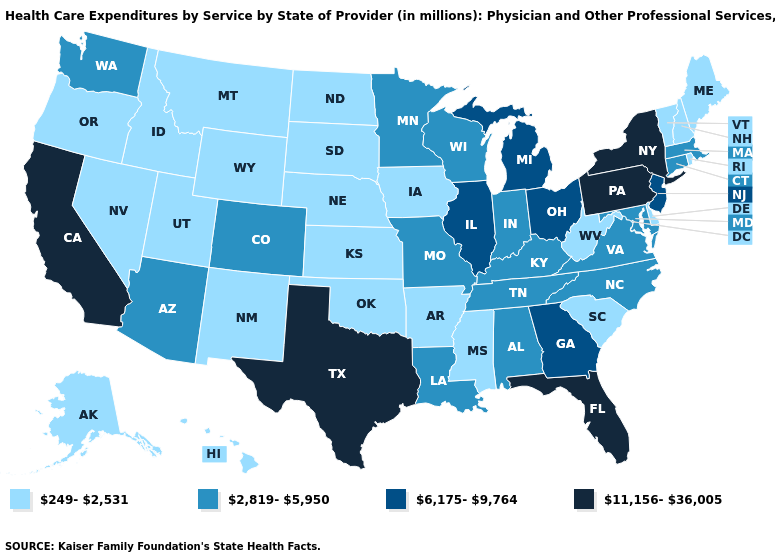Does Texas have the highest value in the USA?
Answer briefly. Yes. Among the states that border South Dakota , which have the highest value?
Give a very brief answer. Minnesota. Name the states that have a value in the range 249-2,531?
Answer briefly. Alaska, Arkansas, Delaware, Hawaii, Idaho, Iowa, Kansas, Maine, Mississippi, Montana, Nebraska, Nevada, New Hampshire, New Mexico, North Dakota, Oklahoma, Oregon, Rhode Island, South Carolina, South Dakota, Utah, Vermont, West Virginia, Wyoming. Name the states that have a value in the range 11,156-36,005?
Quick response, please. California, Florida, New York, Pennsylvania, Texas. Is the legend a continuous bar?
Concise answer only. No. Name the states that have a value in the range 6,175-9,764?
Short answer required. Georgia, Illinois, Michigan, New Jersey, Ohio. Does the first symbol in the legend represent the smallest category?
Quick response, please. Yes. What is the value of California?
Give a very brief answer. 11,156-36,005. Name the states that have a value in the range 6,175-9,764?
Write a very short answer. Georgia, Illinois, Michigan, New Jersey, Ohio. Name the states that have a value in the range 6,175-9,764?
Be succinct. Georgia, Illinois, Michigan, New Jersey, Ohio. Does the map have missing data?
Be succinct. No. Which states have the highest value in the USA?
Concise answer only. California, Florida, New York, Pennsylvania, Texas. Which states hav the highest value in the South?
Write a very short answer. Florida, Texas. Which states have the highest value in the USA?
Concise answer only. California, Florida, New York, Pennsylvania, Texas. Among the states that border North Dakota , does Minnesota have the lowest value?
Give a very brief answer. No. 